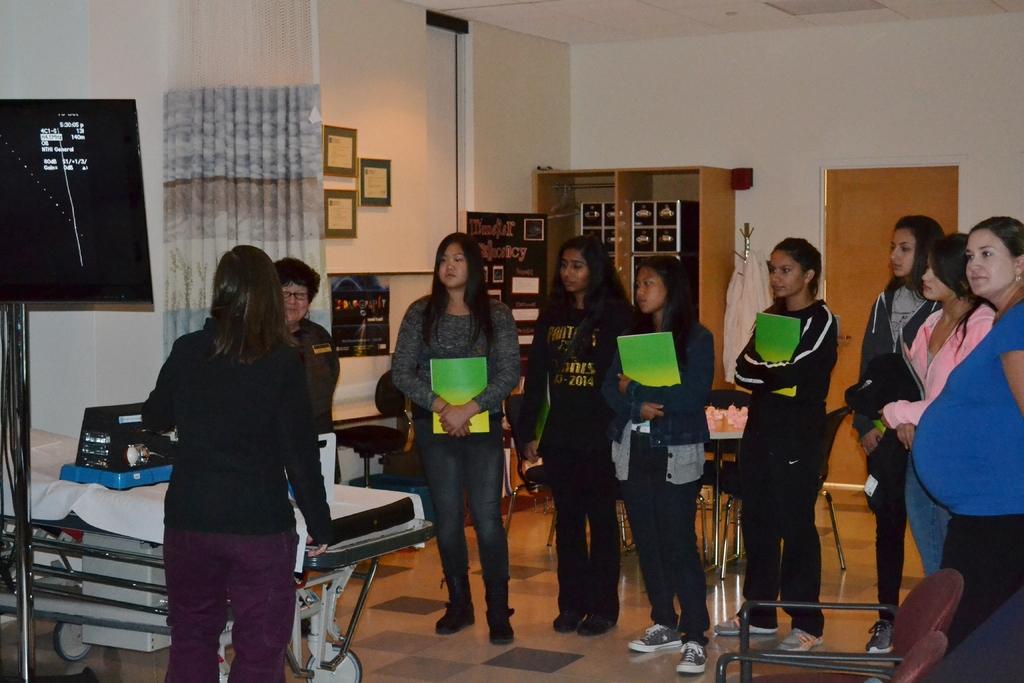How would you summarize this image in a sentence or two? In the picture we can see inside the house with few women are standing and holding green color books and in front of them we can see a stretcher and a woman standing near it and on the stretcher we can see a material and a screen on top of it and beside it we can see a curtain and behind it we can see a wall with some photo frames and near the women we can see some chairs. 